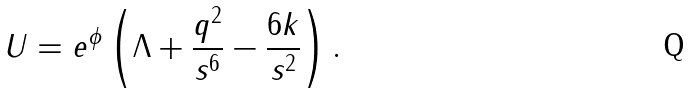<formula> <loc_0><loc_0><loc_500><loc_500>U = e ^ { \phi } \left ( \Lambda + \frac { q ^ { 2 } } { s ^ { 6 } } - \frac { 6 k } { s ^ { 2 } } \right ) .</formula> 